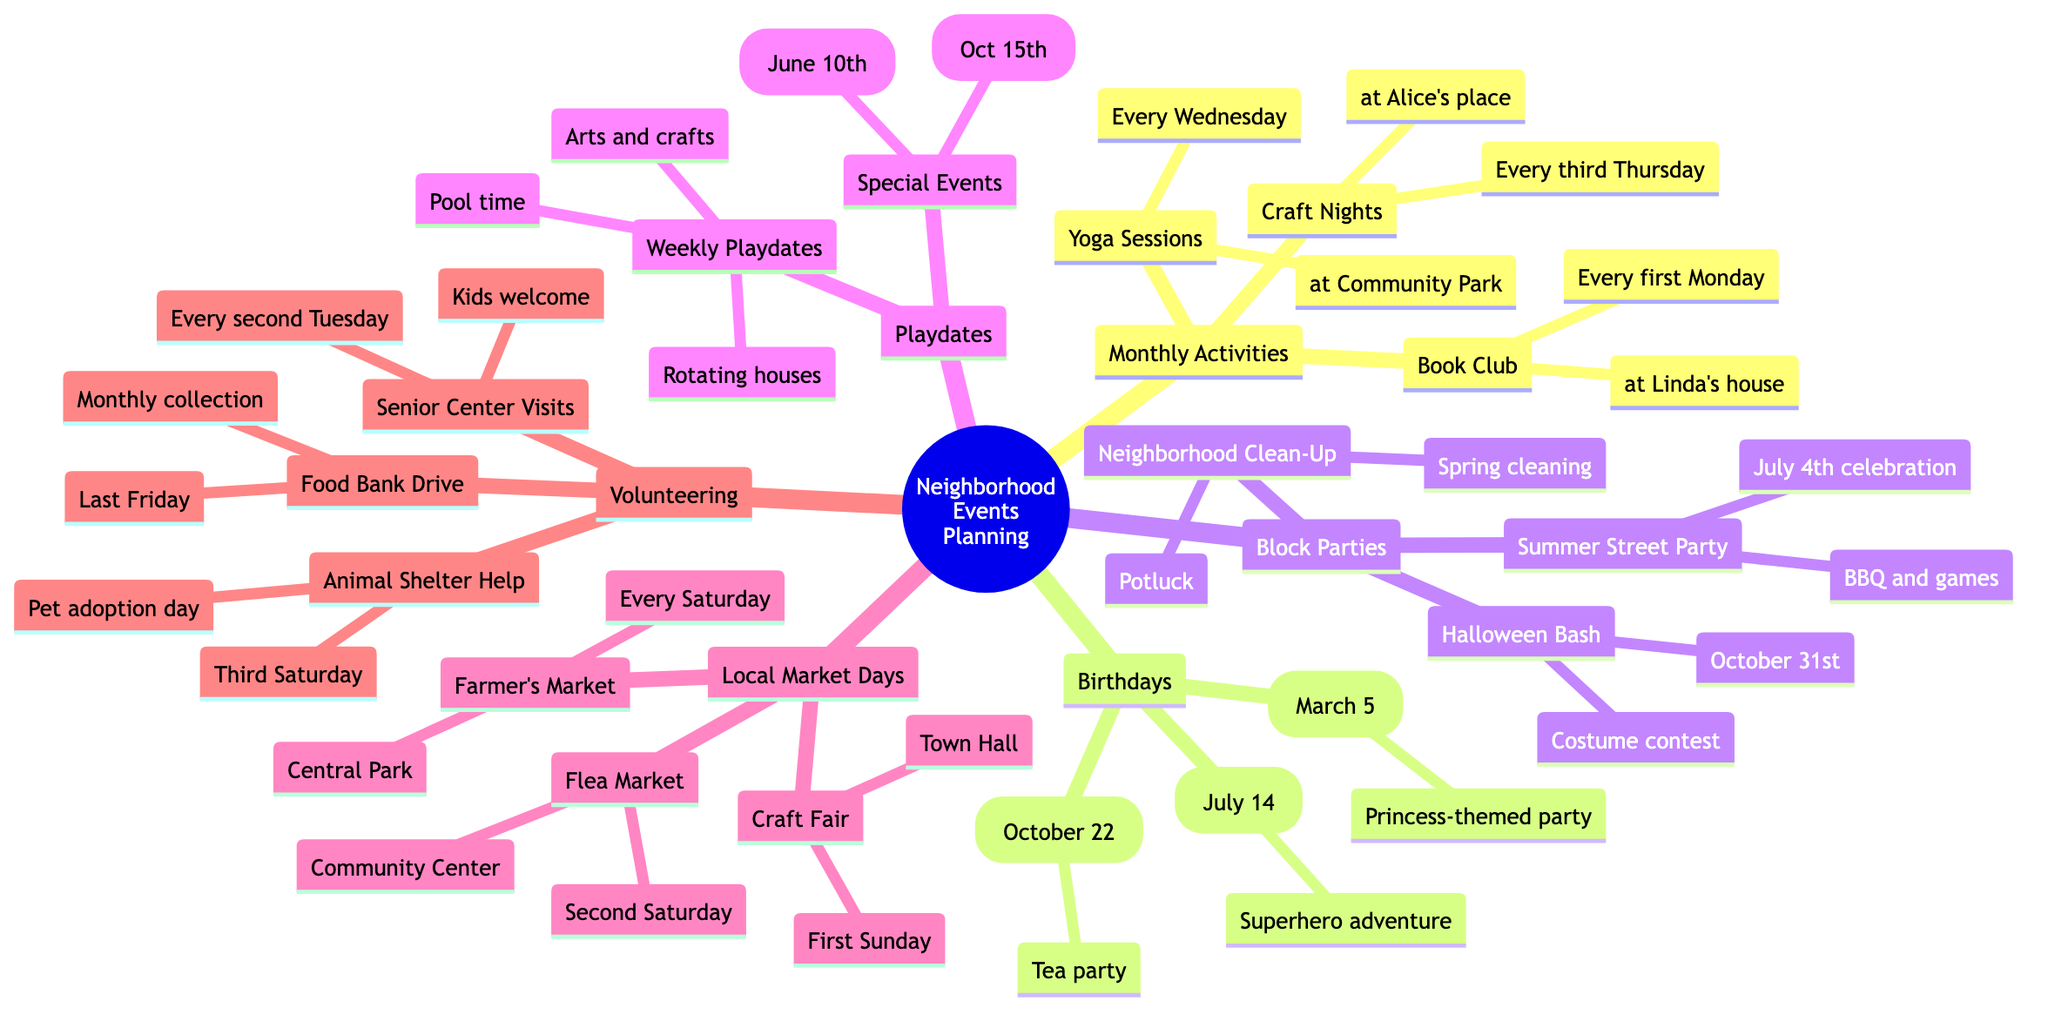What is hosted at Linda's house? According to the diagram, the Book Club meets at Linda's house every first Monday. Thus, the answer is specifically referring to the event associated with her location.
Answer: Book Club When is Jason's birthday party? The diagram shows that Jason's birthday is on July 14. Therefore, the specific date for his birthday celebration is directly taken from that.
Answer: July 14 How often does the Farmer's Market occur? The diagram indicates that the Farmer's Market is held every Saturday morning. This frequency represents how often the event takes place, and it highlights the regularity of the occurrence.
Answer: Every Saturday What is the special event planned for June? The diagram lists a Zoo Trip scheduled for June 10th under the Special Events in the Playdates category. Thus, this event is what is planned for June.
Answer: Zoo Trip How many block parties are listed in the diagram? By counting the block parties mentioned in the diagram, there are three specific events: the Summer Street Party, Halloween Bash, and Neighborhood Clean-Up. This makes the total number of block parties explicitly stated.
Answer: 3 What type of party is being planned for Sophia? The diagram indicates that Sophia is hosting a tea party for her birthday on October 22. This directly answers what kind of party she is planning.
Answer: Tea party What day is the Food Bank Drive collected? The additional details in the Volunteering Opportunities section state that the Food Bank Drive occurs every last Friday of the month. This identifies the specific timing of that event.
Answer: Last Friday How often do weekly playdates occur? The weekly playdates are mentioned to occur at rotating houses each week, which indicates the frequency of this activity is every week. Hence, this directly reflects the periodicity mentioned in the diagram.
Answer: Every week 